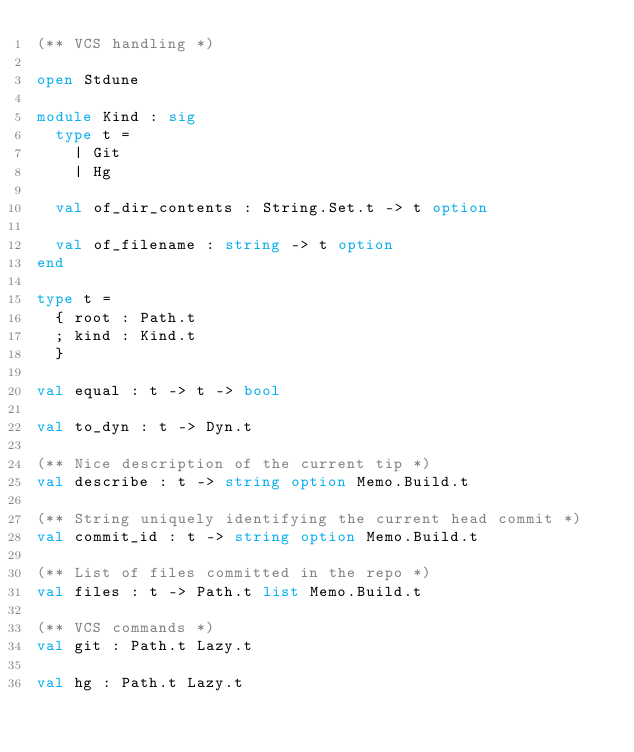<code> <loc_0><loc_0><loc_500><loc_500><_OCaml_>(** VCS handling *)

open Stdune

module Kind : sig
  type t =
    | Git
    | Hg

  val of_dir_contents : String.Set.t -> t option

  val of_filename : string -> t option
end

type t =
  { root : Path.t
  ; kind : Kind.t
  }

val equal : t -> t -> bool

val to_dyn : t -> Dyn.t

(** Nice description of the current tip *)
val describe : t -> string option Memo.Build.t

(** String uniquely identifying the current head commit *)
val commit_id : t -> string option Memo.Build.t

(** List of files committed in the repo *)
val files : t -> Path.t list Memo.Build.t

(** VCS commands *)
val git : Path.t Lazy.t

val hg : Path.t Lazy.t
</code> 